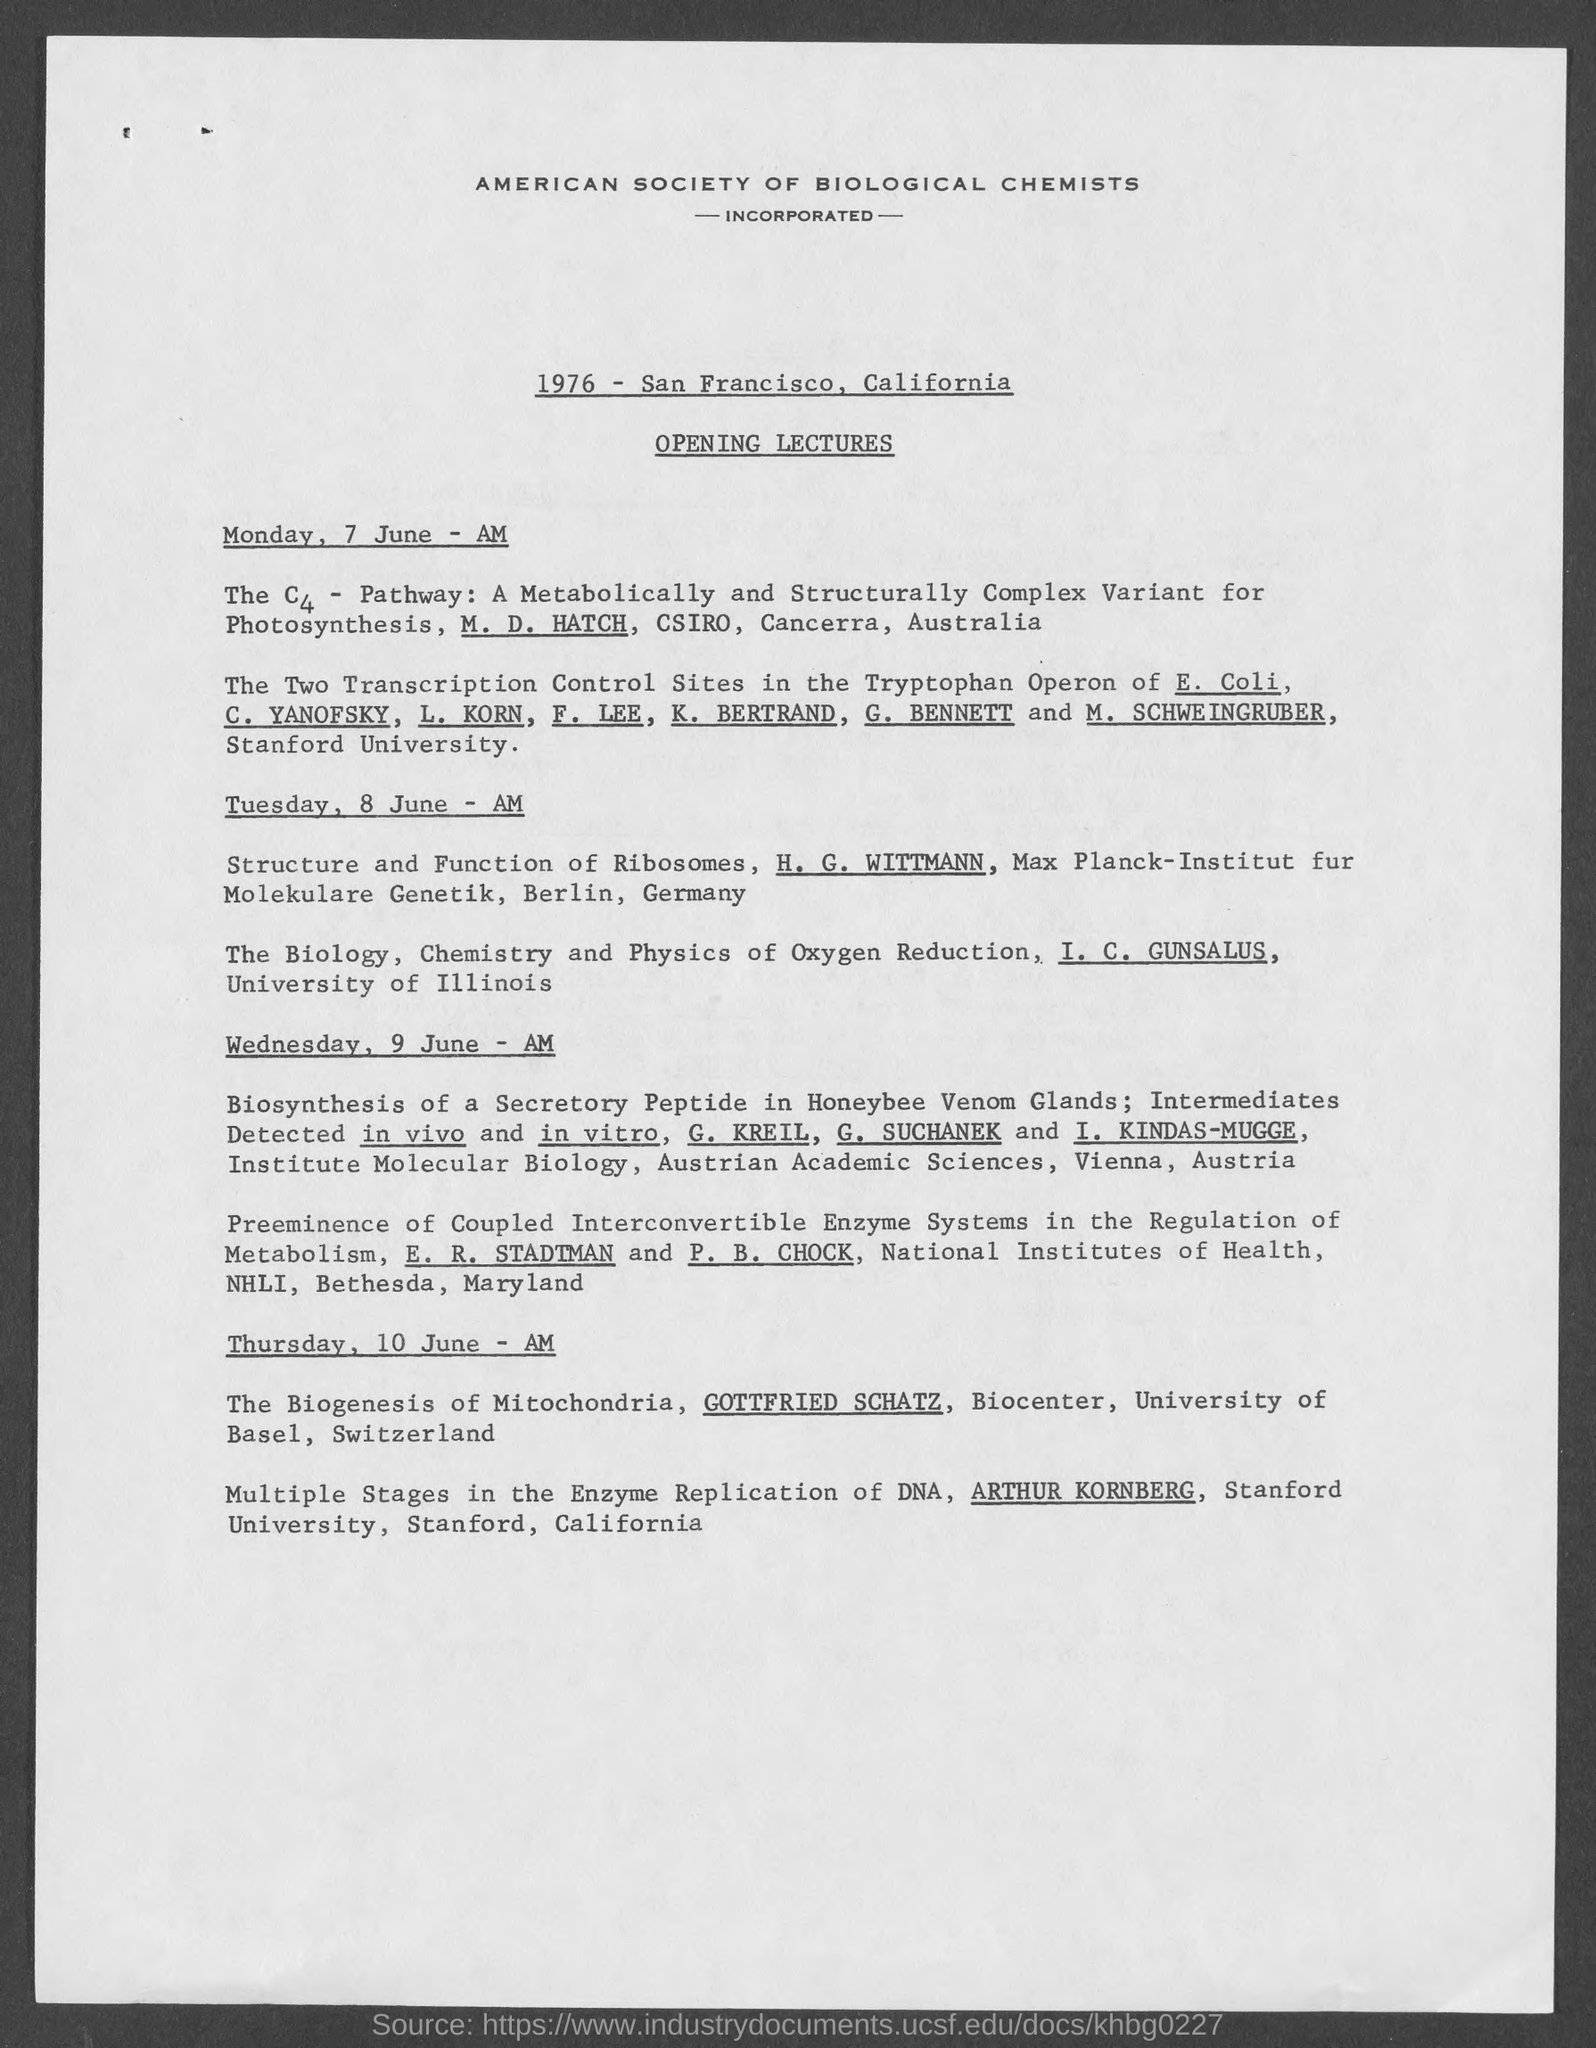When is the lecture on the c4 - pathway?
Provide a succinct answer. Monday, 7 june - am. Who is giving lecture on the biology , chemistry and physics of oxygen reduction?
Keep it short and to the point. I. c. gunsalus. Which university is i. c. gunsalus from?
Offer a very short reply. University of illinois. Where is university of basel?
Offer a very short reply. Switzerland. 